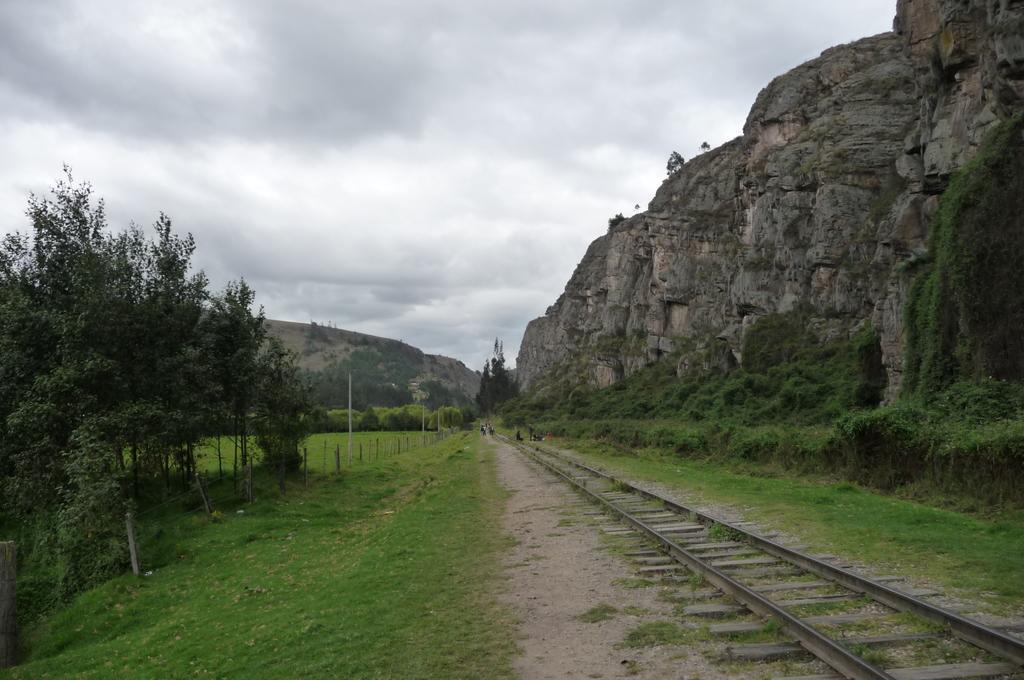Please provide a concise description of this image. In this image, we can see a track in beside the hill. There are some trees on the left side of the image. There is a sky at the top of the image. 